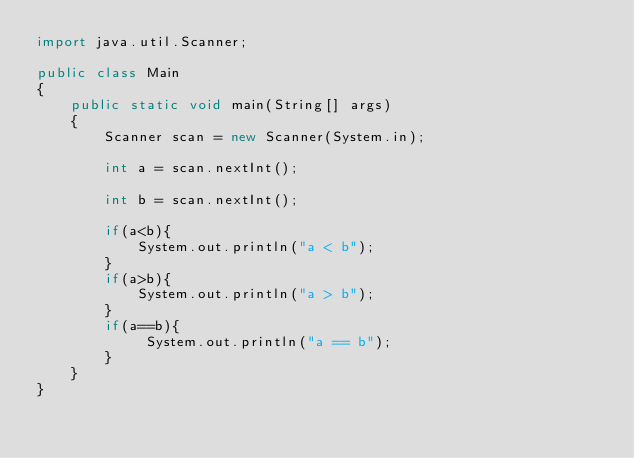Convert code to text. <code><loc_0><loc_0><loc_500><loc_500><_Java_>import java.util.Scanner;

public class Main
{  
    public static void main(String[] args) 
    {
        Scanner scan = new Scanner(System.in);

        int a = scan.nextInt();

        int b = scan.nextInt();
        
        if(a<b){
            System.out.println("a < b");
        }
        if(a>b){
            System.out.println("a > b");
        }
        if(a==b){
             System.out.println("a == b");
        }
    } 
}
</code> 